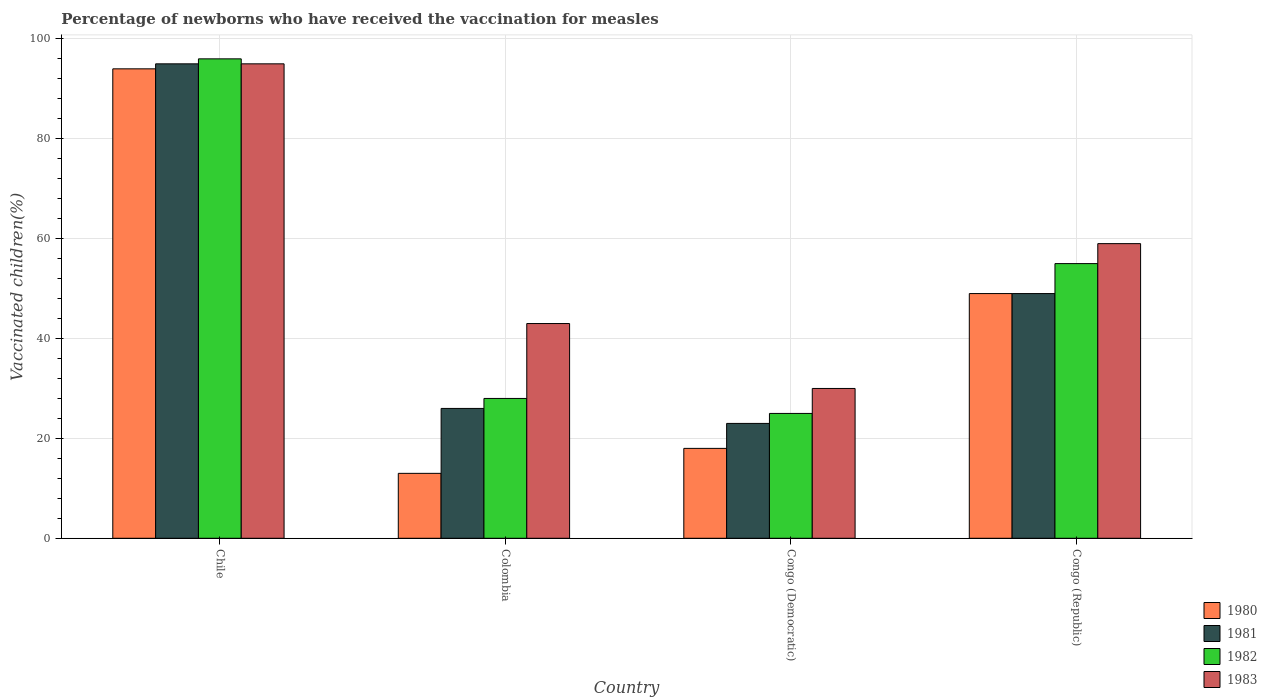How many groups of bars are there?
Give a very brief answer. 4. Are the number of bars per tick equal to the number of legend labels?
Offer a terse response. Yes. How many bars are there on the 2nd tick from the right?
Provide a short and direct response. 4. In how many cases, is the number of bars for a given country not equal to the number of legend labels?
Your answer should be very brief. 0. Across all countries, what is the maximum percentage of vaccinated children in 1981?
Your response must be concise. 95. In which country was the percentage of vaccinated children in 1983 minimum?
Offer a terse response. Congo (Democratic). What is the total percentage of vaccinated children in 1982 in the graph?
Make the answer very short. 204. What is the difference between the percentage of vaccinated children in 1980 in Colombia and that in Congo (Republic)?
Offer a terse response. -36. What is the difference between the percentage of vaccinated children in 1981 in Congo (Democratic) and the percentage of vaccinated children in 1980 in Congo (Republic)?
Make the answer very short. -26. What is the average percentage of vaccinated children in 1982 per country?
Keep it short and to the point. 51. In how many countries, is the percentage of vaccinated children in 1983 greater than 28 %?
Your answer should be compact. 4. What is the ratio of the percentage of vaccinated children in 1983 in Congo (Democratic) to that in Congo (Republic)?
Give a very brief answer. 0.51. Is the difference between the percentage of vaccinated children in 1980 in Chile and Congo (Democratic) greater than the difference between the percentage of vaccinated children in 1983 in Chile and Congo (Democratic)?
Offer a very short reply. Yes. What is the difference between the highest and the second highest percentage of vaccinated children in 1982?
Offer a very short reply. 68. In how many countries, is the percentage of vaccinated children in 1983 greater than the average percentage of vaccinated children in 1983 taken over all countries?
Your answer should be very brief. 2. What does the 1st bar from the left in Congo (Democratic) represents?
Ensure brevity in your answer.  1980. Are all the bars in the graph horizontal?
Give a very brief answer. No. How many countries are there in the graph?
Offer a very short reply. 4. Does the graph contain any zero values?
Provide a succinct answer. No. Does the graph contain grids?
Provide a short and direct response. Yes. Where does the legend appear in the graph?
Offer a terse response. Bottom right. How many legend labels are there?
Keep it short and to the point. 4. How are the legend labels stacked?
Offer a very short reply. Vertical. What is the title of the graph?
Offer a terse response. Percentage of newborns who have received the vaccination for measles. What is the label or title of the Y-axis?
Make the answer very short. Vaccinated children(%). What is the Vaccinated children(%) in 1980 in Chile?
Make the answer very short. 94. What is the Vaccinated children(%) of 1981 in Chile?
Make the answer very short. 95. What is the Vaccinated children(%) of 1982 in Chile?
Provide a short and direct response. 96. What is the Vaccinated children(%) of 1983 in Chile?
Your answer should be very brief. 95. What is the Vaccinated children(%) of 1980 in Colombia?
Keep it short and to the point. 13. What is the Vaccinated children(%) of 1981 in Colombia?
Your answer should be compact. 26. What is the Vaccinated children(%) of 1983 in Colombia?
Offer a terse response. 43. What is the Vaccinated children(%) of 1981 in Congo (Democratic)?
Offer a terse response. 23. What is the Vaccinated children(%) of 1983 in Congo (Democratic)?
Provide a short and direct response. 30. What is the Vaccinated children(%) of 1980 in Congo (Republic)?
Provide a short and direct response. 49. What is the Vaccinated children(%) of 1981 in Congo (Republic)?
Give a very brief answer. 49. What is the Vaccinated children(%) of 1982 in Congo (Republic)?
Give a very brief answer. 55. Across all countries, what is the maximum Vaccinated children(%) in 1980?
Your answer should be compact. 94. Across all countries, what is the maximum Vaccinated children(%) of 1981?
Give a very brief answer. 95. Across all countries, what is the maximum Vaccinated children(%) of 1982?
Offer a very short reply. 96. Across all countries, what is the maximum Vaccinated children(%) of 1983?
Provide a short and direct response. 95. Across all countries, what is the minimum Vaccinated children(%) in 1982?
Your answer should be compact. 25. Across all countries, what is the minimum Vaccinated children(%) in 1983?
Keep it short and to the point. 30. What is the total Vaccinated children(%) in 1980 in the graph?
Give a very brief answer. 174. What is the total Vaccinated children(%) in 1981 in the graph?
Your answer should be very brief. 193. What is the total Vaccinated children(%) of 1982 in the graph?
Offer a very short reply. 204. What is the total Vaccinated children(%) in 1983 in the graph?
Your answer should be compact. 227. What is the difference between the Vaccinated children(%) of 1983 in Chile and that in Colombia?
Your answer should be compact. 52. What is the difference between the Vaccinated children(%) in 1982 in Chile and that in Congo (Democratic)?
Ensure brevity in your answer.  71. What is the difference between the Vaccinated children(%) in 1981 in Chile and that in Congo (Republic)?
Keep it short and to the point. 46. What is the difference between the Vaccinated children(%) of 1981 in Colombia and that in Congo (Democratic)?
Give a very brief answer. 3. What is the difference between the Vaccinated children(%) of 1982 in Colombia and that in Congo (Democratic)?
Offer a terse response. 3. What is the difference between the Vaccinated children(%) in 1980 in Colombia and that in Congo (Republic)?
Offer a terse response. -36. What is the difference between the Vaccinated children(%) of 1981 in Colombia and that in Congo (Republic)?
Provide a short and direct response. -23. What is the difference between the Vaccinated children(%) of 1983 in Colombia and that in Congo (Republic)?
Your response must be concise. -16. What is the difference between the Vaccinated children(%) of 1980 in Congo (Democratic) and that in Congo (Republic)?
Your response must be concise. -31. What is the difference between the Vaccinated children(%) of 1981 in Congo (Democratic) and that in Congo (Republic)?
Ensure brevity in your answer.  -26. What is the difference between the Vaccinated children(%) of 1983 in Congo (Democratic) and that in Congo (Republic)?
Offer a terse response. -29. What is the difference between the Vaccinated children(%) of 1980 in Chile and the Vaccinated children(%) of 1981 in Colombia?
Your answer should be very brief. 68. What is the difference between the Vaccinated children(%) of 1980 in Chile and the Vaccinated children(%) of 1982 in Colombia?
Your response must be concise. 66. What is the difference between the Vaccinated children(%) in 1981 in Chile and the Vaccinated children(%) in 1983 in Colombia?
Provide a succinct answer. 52. What is the difference between the Vaccinated children(%) in 1982 in Chile and the Vaccinated children(%) in 1983 in Colombia?
Provide a short and direct response. 53. What is the difference between the Vaccinated children(%) of 1980 in Chile and the Vaccinated children(%) of 1981 in Congo (Democratic)?
Ensure brevity in your answer.  71. What is the difference between the Vaccinated children(%) of 1981 in Chile and the Vaccinated children(%) of 1982 in Congo (Democratic)?
Your answer should be very brief. 70. What is the difference between the Vaccinated children(%) in 1980 in Chile and the Vaccinated children(%) in 1981 in Congo (Republic)?
Your answer should be compact. 45. What is the difference between the Vaccinated children(%) of 1980 in Chile and the Vaccinated children(%) of 1983 in Congo (Republic)?
Provide a succinct answer. 35. What is the difference between the Vaccinated children(%) of 1980 in Colombia and the Vaccinated children(%) of 1982 in Congo (Democratic)?
Offer a very short reply. -12. What is the difference between the Vaccinated children(%) in 1981 in Colombia and the Vaccinated children(%) in 1983 in Congo (Democratic)?
Ensure brevity in your answer.  -4. What is the difference between the Vaccinated children(%) in 1980 in Colombia and the Vaccinated children(%) in 1981 in Congo (Republic)?
Offer a terse response. -36. What is the difference between the Vaccinated children(%) in 1980 in Colombia and the Vaccinated children(%) in 1982 in Congo (Republic)?
Your answer should be compact. -42. What is the difference between the Vaccinated children(%) in 1980 in Colombia and the Vaccinated children(%) in 1983 in Congo (Republic)?
Your answer should be compact. -46. What is the difference between the Vaccinated children(%) in 1981 in Colombia and the Vaccinated children(%) in 1982 in Congo (Republic)?
Make the answer very short. -29. What is the difference between the Vaccinated children(%) of 1981 in Colombia and the Vaccinated children(%) of 1983 in Congo (Republic)?
Offer a very short reply. -33. What is the difference between the Vaccinated children(%) in 1982 in Colombia and the Vaccinated children(%) in 1983 in Congo (Republic)?
Provide a short and direct response. -31. What is the difference between the Vaccinated children(%) of 1980 in Congo (Democratic) and the Vaccinated children(%) of 1981 in Congo (Republic)?
Offer a terse response. -31. What is the difference between the Vaccinated children(%) of 1980 in Congo (Democratic) and the Vaccinated children(%) of 1982 in Congo (Republic)?
Give a very brief answer. -37. What is the difference between the Vaccinated children(%) in 1980 in Congo (Democratic) and the Vaccinated children(%) in 1983 in Congo (Republic)?
Make the answer very short. -41. What is the difference between the Vaccinated children(%) of 1981 in Congo (Democratic) and the Vaccinated children(%) of 1982 in Congo (Republic)?
Your response must be concise. -32. What is the difference between the Vaccinated children(%) of 1981 in Congo (Democratic) and the Vaccinated children(%) of 1983 in Congo (Republic)?
Make the answer very short. -36. What is the difference between the Vaccinated children(%) of 1982 in Congo (Democratic) and the Vaccinated children(%) of 1983 in Congo (Republic)?
Your response must be concise. -34. What is the average Vaccinated children(%) in 1980 per country?
Your answer should be very brief. 43.5. What is the average Vaccinated children(%) in 1981 per country?
Your response must be concise. 48.25. What is the average Vaccinated children(%) in 1983 per country?
Your response must be concise. 56.75. What is the difference between the Vaccinated children(%) of 1980 and Vaccinated children(%) of 1981 in Chile?
Make the answer very short. -1. What is the difference between the Vaccinated children(%) of 1980 and Vaccinated children(%) of 1982 in Chile?
Your answer should be very brief. -2. What is the difference between the Vaccinated children(%) of 1982 and Vaccinated children(%) of 1983 in Chile?
Make the answer very short. 1. What is the difference between the Vaccinated children(%) of 1980 and Vaccinated children(%) of 1982 in Colombia?
Make the answer very short. -15. What is the difference between the Vaccinated children(%) in 1981 and Vaccinated children(%) in 1983 in Colombia?
Your response must be concise. -17. What is the difference between the Vaccinated children(%) of 1982 and Vaccinated children(%) of 1983 in Colombia?
Your answer should be compact. -15. What is the difference between the Vaccinated children(%) in 1980 and Vaccinated children(%) in 1982 in Congo (Democratic)?
Make the answer very short. -7. What is the difference between the Vaccinated children(%) of 1982 and Vaccinated children(%) of 1983 in Congo (Democratic)?
Provide a succinct answer. -5. What is the difference between the Vaccinated children(%) of 1980 and Vaccinated children(%) of 1982 in Congo (Republic)?
Offer a terse response. -6. What is the difference between the Vaccinated children(%) in 1981 and Vaccinated children(%) in 1982 in Congo (Republic)?
Make the answer very short. -6. What is the difference between the Vaccinated children(%) of 1981 and Vaccinated children(%) of 1983 in Congo (Republic)?
Ensure brevity in your answer.  -10. What is the ratio of the Vaccinated children(%) in 1980 in Chile to that in Colombia?
Your answer should be compact. 7.23. What is the ratio of the Vaccinated children(%) of 1981 in Chile to that in Colombia?
Your answer should be very brief. 3.65. What is the ratio of the Vaccinated children(%) of 1982 in Chile to that in Colombia?
Offer a terse response. 3.43. What is the ratio of the Vaccinated children(%) of 1983 in Chile to that in Colombia?
Make the answer very short. 2.21. What is the ratio of the Vaccinated children(%) in 1980 in Chile to that in Congo (Democratic)?
Provide a succinct answer. 5.22. What is the ratio of the Vaccinated children(%) of 1981 in Chile to that in Congo (Democratic)?
Offer a terse response. 4.13. What is the ratio of the Vaccinated children(%) of 1982 in Chile to that in Congo (Democratic)?
Give a very brief answer. 3.84. What is the ratio of the Vaccinated children(%) in 1983 in Chile to that in Congo (Democratic)?
Your response must be concise. 3.17. What is the ratio of the Vaccinated children(%) in 1980 in Chile to that in Congo (Republic)?
Keep it short and to the point. 1.92. What is the ratio of the Vaccinated children(%) in 1981 in Chile to that in Congo (Republic)?
Give a very brief answer. 1.94. What is the ratio of the Vaccinated children(%) of 1982 in Chile to that in Congo (Republic)?
Provide a succinct answer. 1.75. What is the ratio of the Vaccinated children(%) of 1983 in Chile to that in Congo (Republic)?
Give a very brief answer. 1.61. What is the ratio of the Vaccinated children(%) in 1980 in Colombia to that in Congo (Democratic)?
Keep it short and to the point. 0.72. What is the ratio of the Vaccinated children(%) of 1981 in Colombia to that in Congo (Democratic)?
Give a very brief answer. 1.13. What is the ratio of the Vaccinated children(%) of 1982 in Colombia to that in Congo (Democratic)?
Your answer should be very brief. 1.12. What is the ratio of the Vaccinated children(%) of 1983 in Colombia to that in Congo (Democratic)?
Give a very brief answer. 1.43. What is the ratio of the Vaccinated children(%) in 1980 in Colombia to that in Congo (Republic)?
Keep it short and to the point. 0.27. What is the ratio of the Vaccinated children(%) of 1981 in Colombia to that in Congo (Republic)?
Your answer should be very brief. 0.53. What is the ratio of the Vaccinated children(%) of 1982 in Colombia to that in Congo (Republic)?
Your answer should be very brief. 0.51. What is the ratio of the Vaccinated children(%) in 1983 in Colombia to that in Congo (Republic)?
Your answer should be very brief. 0.73. What is the ratio of the Vaccinated children(%) of 1980 in Congo (Democratic) to that in Congo (Republic)?
Offer a very short reply. 0.37. What is the ratio of the Vaccinated children(%) of 1981 in Congo (Democratic) to that in Congo (Republic)?
Your response must be concise. 0.47. What is the ratio of the Vaccinated children(%) in 1982 in Congo (Democratic) to that in Congo (Republic)?
Your response must be concise. 0.45. What is the ratio of the Vaccinated children(%) in 1983 in Congo (Democratic) to that in Congo (Republic)?
Provide a short and direct response. 0.51. What is the difference between the highest and the second highest Vaccinated children(%) of 1980?
Ensure brevity in your answer.  45. What is the difference between the highest and the second highest Vaccinated children(%) in 1981?
Ensure brevity in your answer.  46. What is the difference between the highest and the second highest Vaccinated children(%) in 1983?
Give a very brief answer. 36. What is the difference between the highest and the lowest Vaccinated children(%) of 1980?
Provide a succinct answer. 81. 